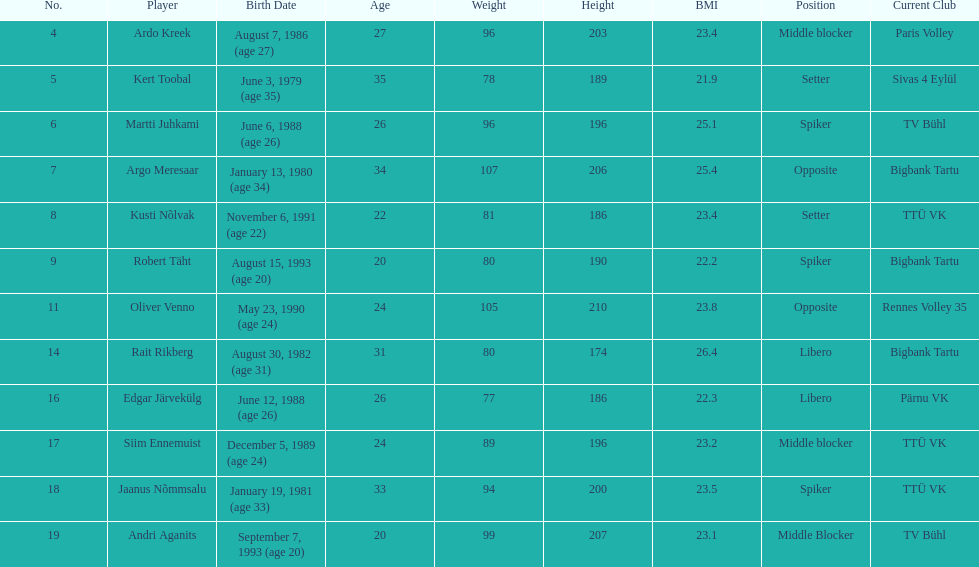Who is the highest member of estonia's men's national volleyball team? Oliver Venno. 